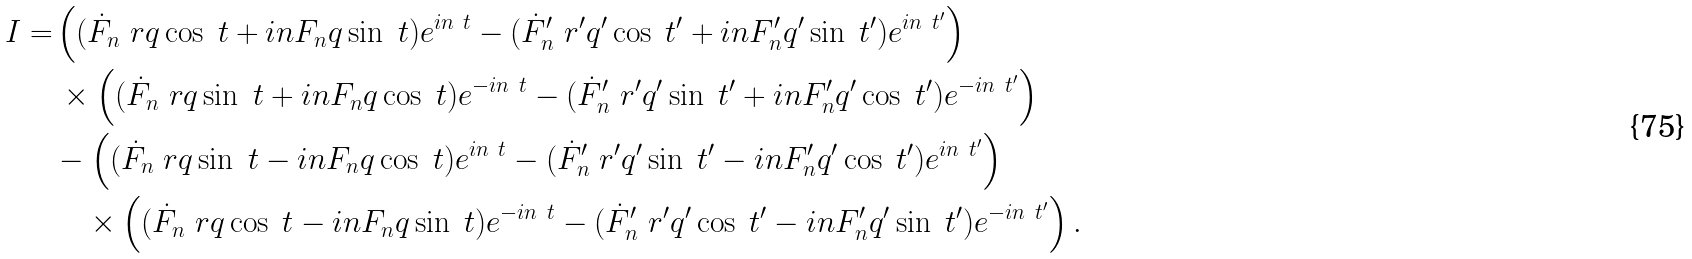Convert formula to latex. <formula><loc_0><loc_0><loc_500><loc_500>I = & \left ( ( \dot { F } _ { n } \ r q \cos \ t + i n { F } _ { n } q \sin \ t ) e ^ { i n \ t } - ( \dot { F } ^ { \prime } _ { n } \ r ^ { \prime } q ^ { \prime } \cos \ t ^ { \prime } + i n { F } ^ { \prime } _ { n } q ^ { \prime } \sin \ t ^ { \prime } ) e ^ { i n \ t ^ { \prime } } \right ) \\ & \, \times \left ( ( \dot { F } _ { n } \ r q \sin \ t + i n { F } _ { n } q \cos \ t ) e ^ { - i n \ t } - ( \dot { F } ^ { \prime } _ { n } \ r ^ { \prime } q ^ { \prime } \sin \ t ^ { \prime } + i n { F } ^ { \prime } _ { n } q ^ { \prime } \cos \ t ^ { \prime } ) e ^ { - i n \ t ^ { \prime } } \right ) \\ & - \left ( ( \dot { F } _ { n } \ r q \sin \ t - i n { F } _ { n } q \cos \ t ) e ^ { i n \ t } - ( \dot { F } ^ { \prime } _ { n } \ r ^ { \prime } q ^ { \prime } \sin \ t ^ { \prime } - i n { F } ^ { \prime } _ { n } q ^ { \prime } \cos \ t ^ { \prime } ) e ^ { i n \ t ^ { \prime } } \right ) \\ & \quad \times \left ( ( \dot { F } _ { n } \ r q \cos \ t - i n { F } _ { n } q \sin \ t ) e ^ { - i n \ t } - ( \dot { F } ^ { \prime } _ { n } \ r ^ { \prime } q ^ { \prime } \cos \ t ^ { \prime } - i n { F } ^ { \prime } _ { n } q ^ { \prime } \sin \ t ^ { \prime } ) e ^ { - i n \ t ^ { \prime } } \right ) .</formula> 